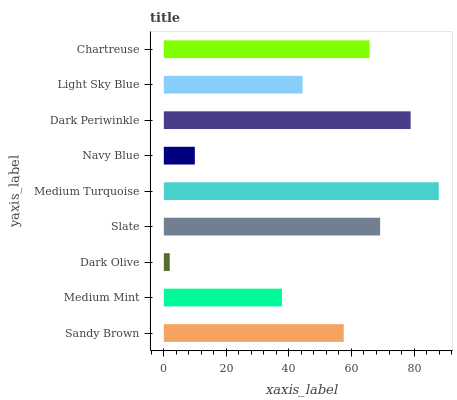Is Dark Olive the minimum?
Answer yes or no. Yes. Is Medium Turquoise the maximum?
Answer yes or no. Yes. Is Medium Mint the minimum?
Answer yes or no. No. Is Medium Mint the maximum?
Answer yes or no. No. Is Sandy Brown greater than Medium Mint?
Answer yes or no. Yes. Is Medium Mint less than Sandy Brown?
Answer yes or no. Yes. Is Medium Mint greater than Sandy Brown?
Answer yes or no. No. Is Sandy Brown less than Medium Mint?
Answer yes or no. No. Is Sandy Brown the high median?
Answer yes or no. Yes. Is Sandy Brown the low median?
Answer yes or no. Yes. Is Dark Periwinkle the high median?
Answer yes or no. No. Is Slate the low median?
Answer yes or no. No. 